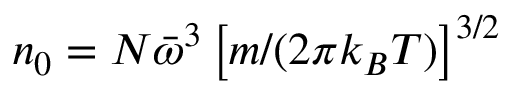<formula> <loc_0><loc_0><loc_500><loc_500>n _ { 0 } = N \bar { \omega } ^ { 3 } \left [ m / ( 2 \pi k _ { B } T ) \right ] ^ { 3 / 2 }</formula> 